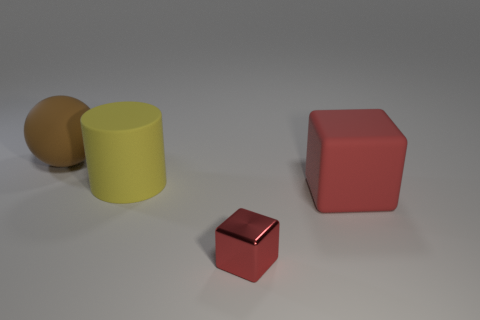How many other things are there of the same material as the large brown sphere? In the image, there appears to be one other item that seems to be made of the same reflective material as the large brown sphere. It is a smaller, similarly shaded object adjacent to the sphere. 